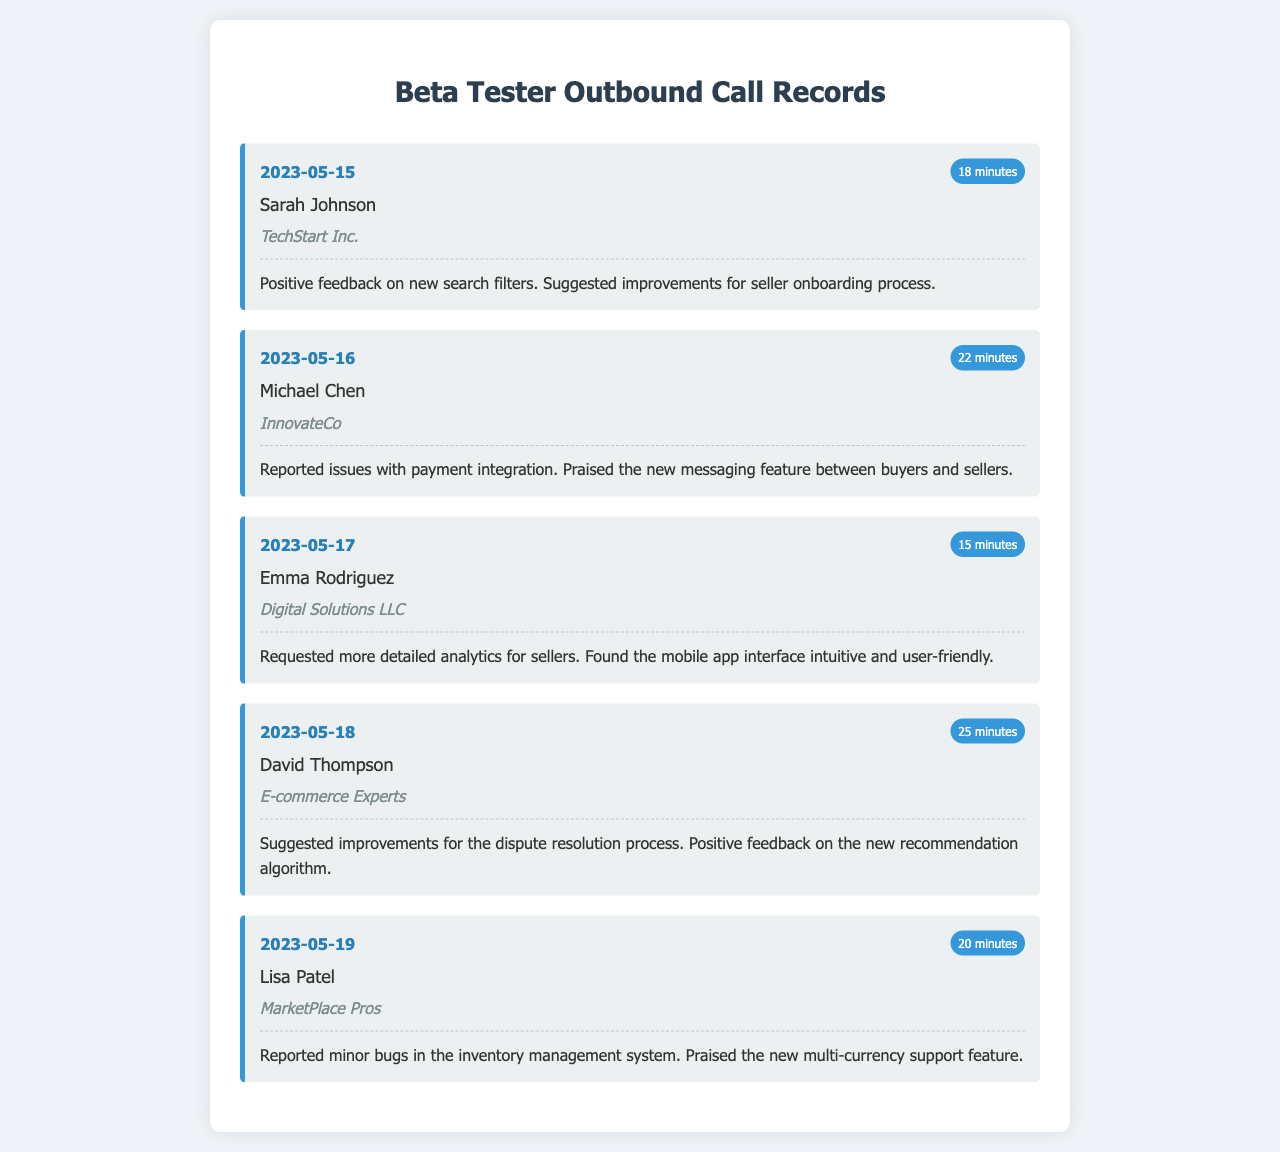What is the name of the tester who provided feedback on seller onboarding? Sarah Johnson suggested improvements for the seller onboarding process during her call on May 15, 2023.
Answer: Sarah Johnson What company does Michael Chen represent? Michael Chen is associated with InnovateCo, as noted in his call record on May 16, 2023.
Answer: InnovateCo How many minutes did the call with David Thompson last? The duration of David Thompson's call on May 18, 2023, was 25 minutes.
Answer: 25 minutes What specific issue did Emma Rodriguez request improvements on? Emma Rodriguez requested more detailed analytics for sellers during her call on May 17, 2023.
Answer: Detailed analytics Which feature was praised by Lisa Patel? Lisa Patel praised the new multi-currency support feature during her feedback on May 19, 2023.
Answer: Multi-currency support What date was the feedback regarding the recommendation algorithm provided? David Thompson provided positive feedback on the new recommendation algorithm during his call on May 18, 2023.
Answer: May 18, 2023 What common theme appears in the feedback about the marketplace's features? Several testers expressed positive feedback while also providing suggestions for improvements regarding various features.
Answer: Positive feedback How many minutes did the shortest call last? The shortest call recorded was with Emma Rodriguez, lasting 15 minutes.
Answer: 15 minutes 